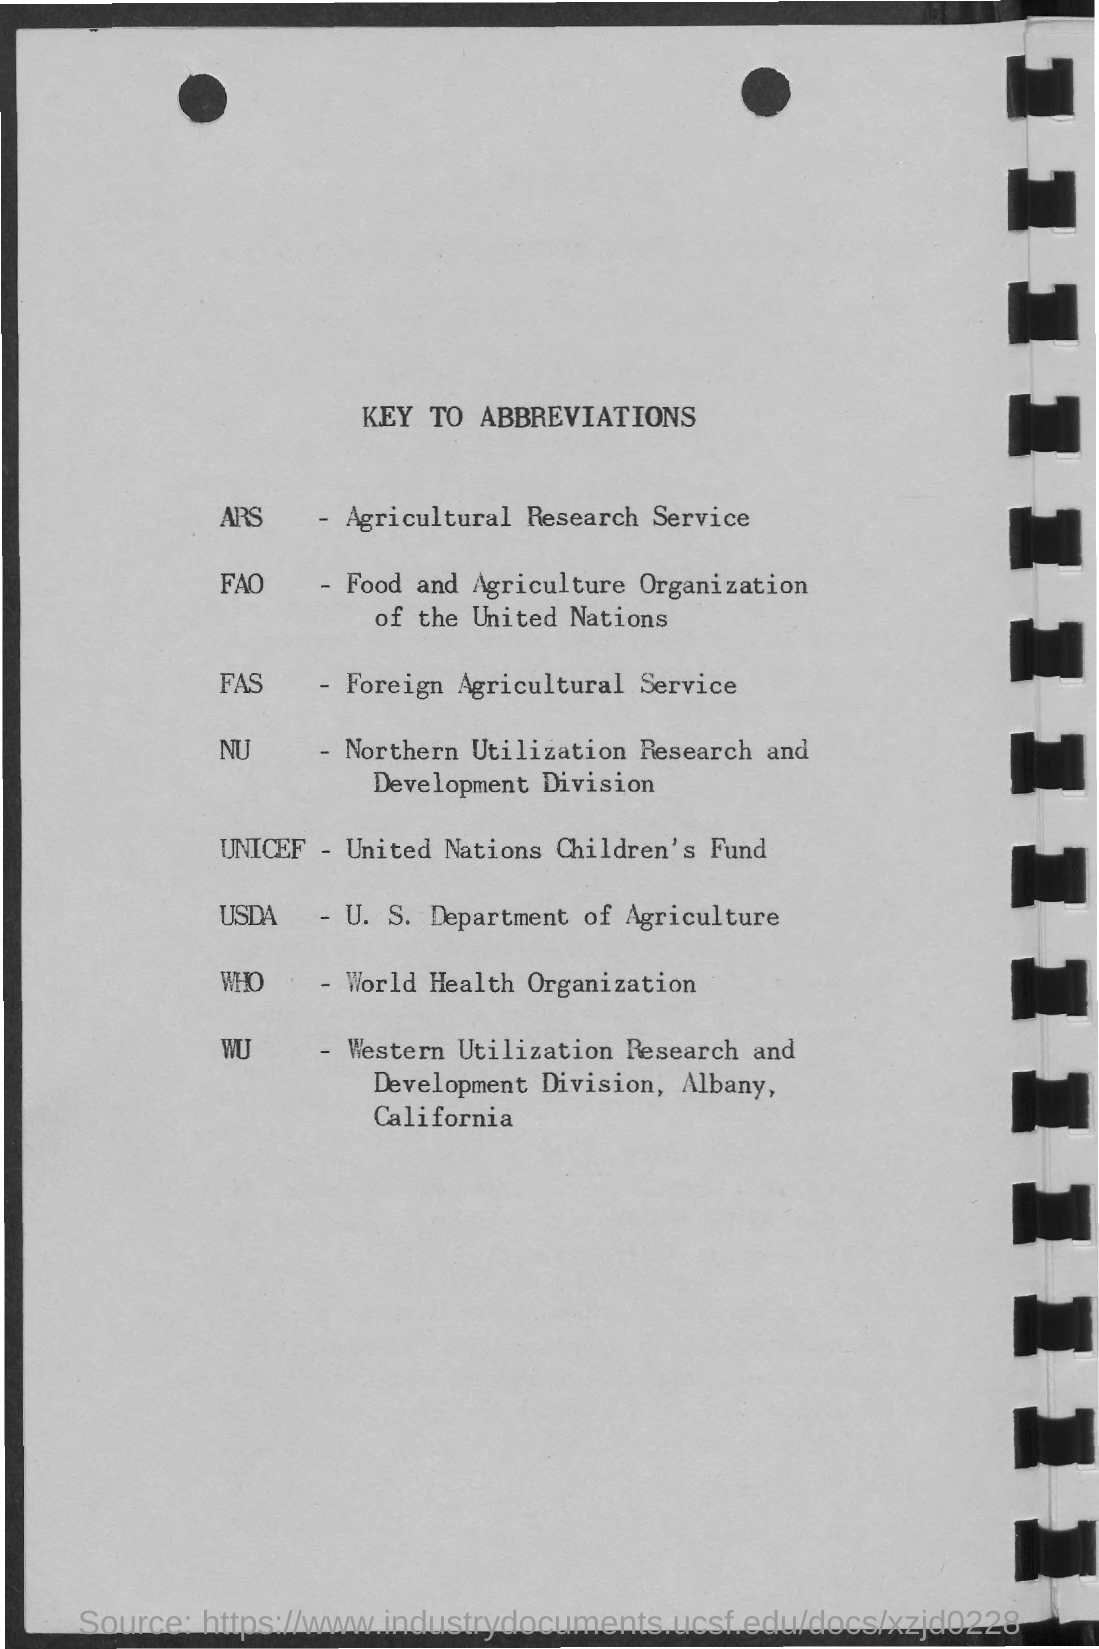What is the fullform of ARS?
Your response must be concise. Agricultural Research Service. What is the fullform of FAS?
Provide a short and direct response. Foreign Agricultural Service. What is the abbreviation for World Health Organization?
Offer a very short reply. WHO. What is the abbreviation for  U. S. Department of Agriculture?
Provide a succinct answer. USDA. What is the fullform of UNICEF?
Make the answer very short. United Nations Children's Fund. 